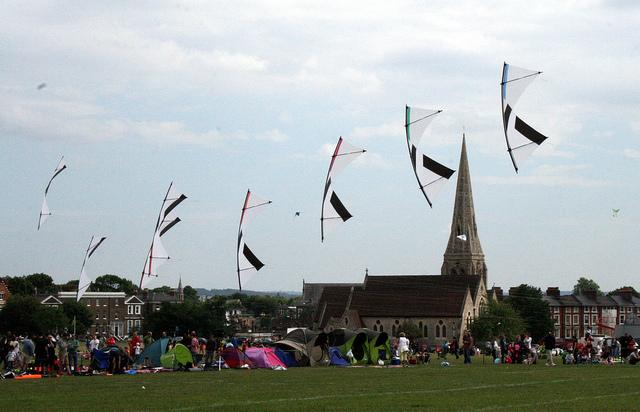What might be taking place in the building to the right? church 